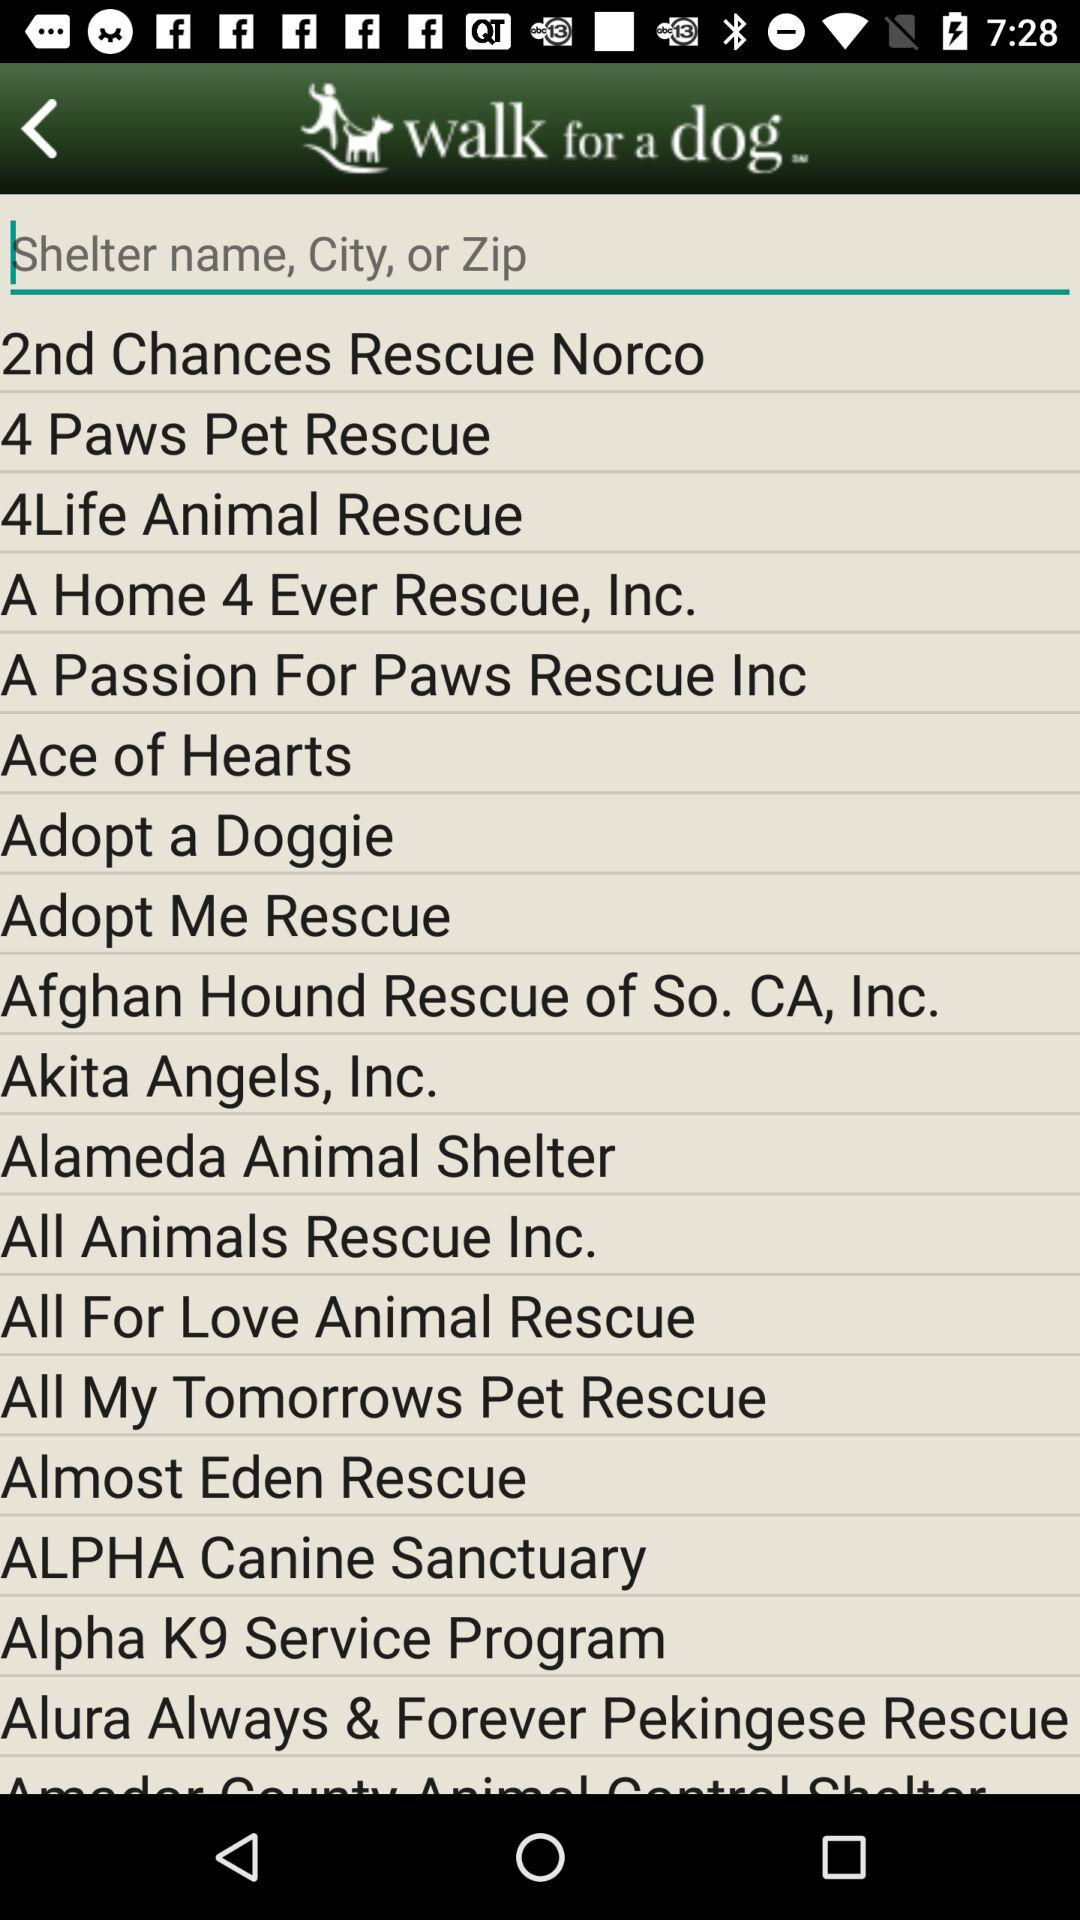Which city is "Adopt a Doggie" in?
When the provided information is insufficient, respond with <no answer>. <no answer> 